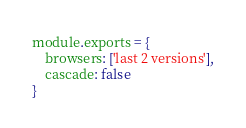<code> <loc_0><loc_0><loc_500><loc_500><_JavaScript_>module.exports = {
    browsers: ['last 2 versions'],
    cascade: false
}
</code> 